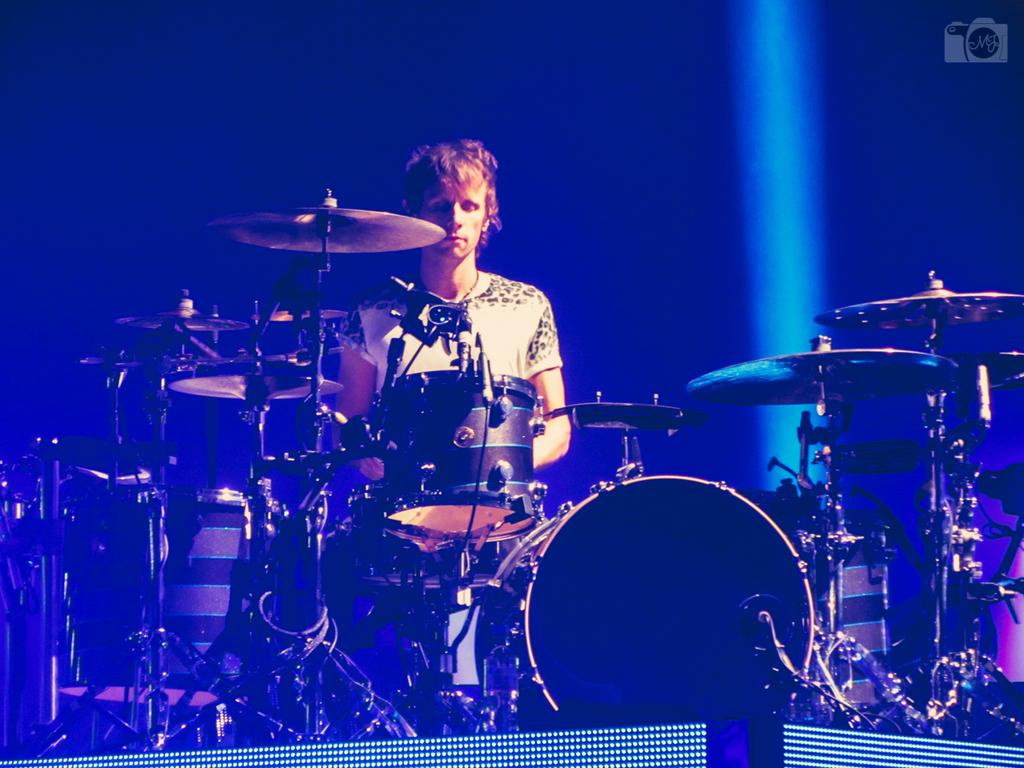What type of event might the image be from? The image might be from a musical concert. What instrument is the main focus of the image? There are drums in the middle of the image. Who is interacting with the drums in the image? A person is playing the drums. What direction are the ants moving in the image? There are no ants present in the image. What type of list can be seen on the drum set in the image? There is no list present in the image; it features a person playing drums. 